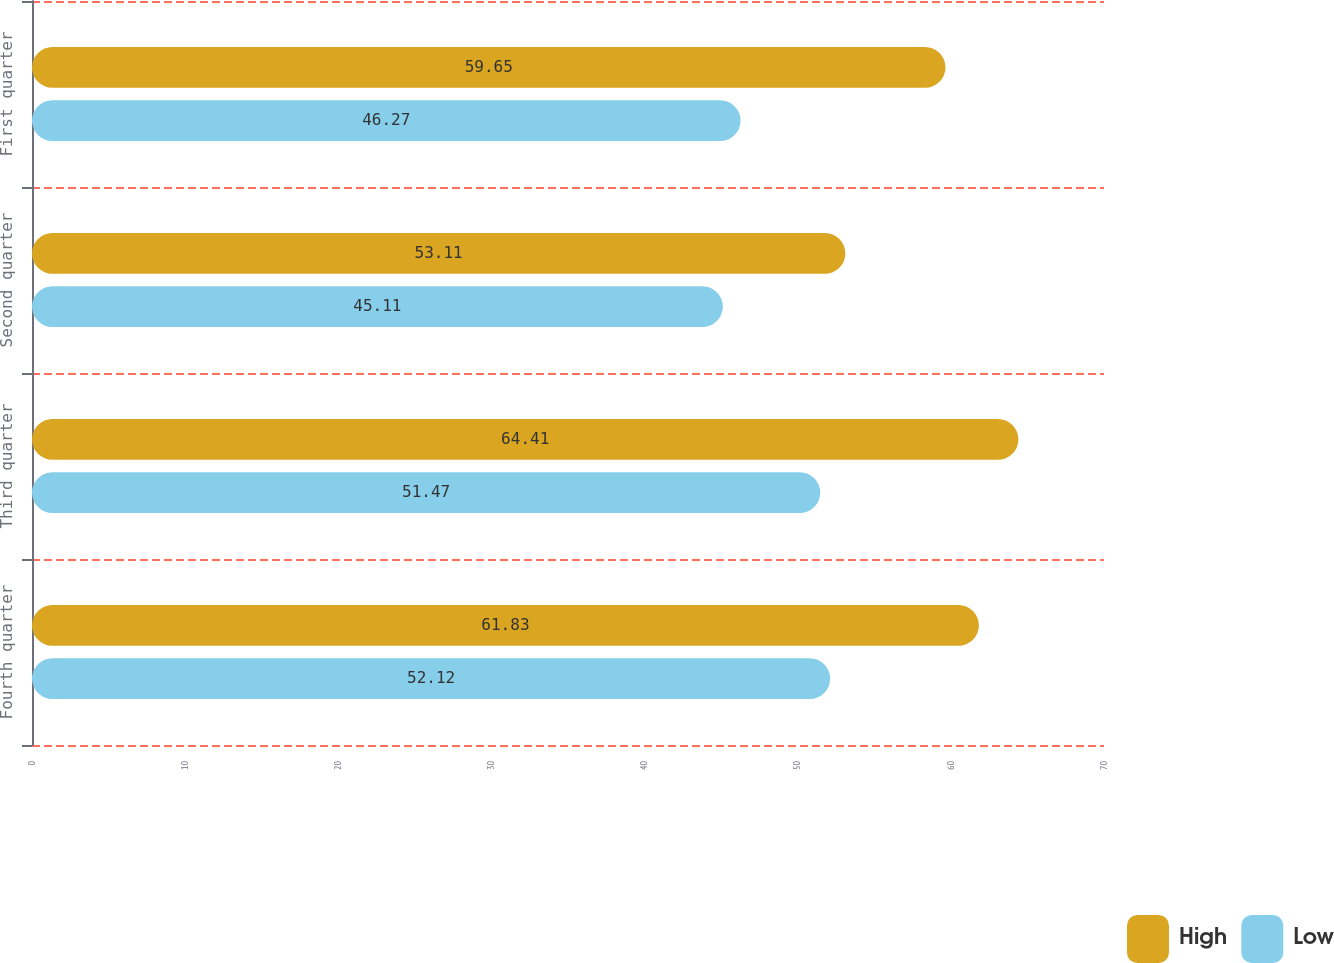Convert chart to OTSL. <chart><loc_0><loc_0><loc_500><loc_500><stacked_bar_chart><ecel><fcel>Fourth quarter<fcel>Third quarter<fcel>Second quarter<fcel>First quarter<nl><fcel>High<fcel>61.83<fcel>64.41<fcel>53.11<fcel>59.65<nl><fcel>Low<fcel>52.12<fcel>51.47<fcel>45.11<fcel>46.27<nl></chart> 